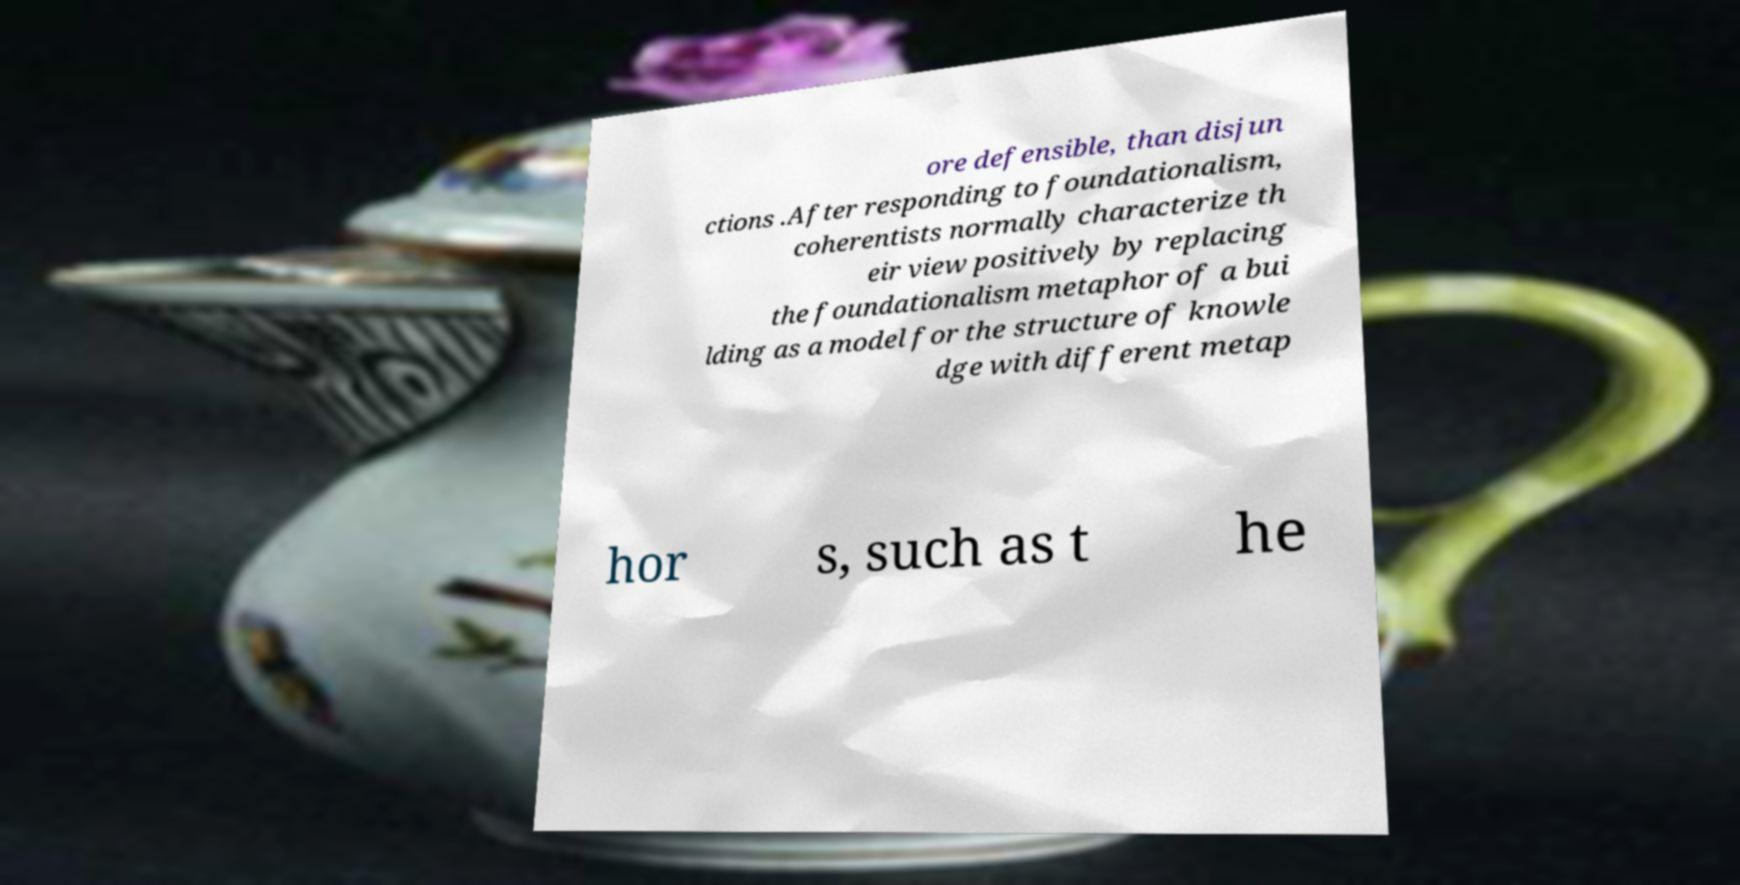Can you read and provide the text displayed in the image?This photo seems to have some interesting text. Can you extract and type it out for me? ore defensible, than disjun ctions .After responding to foundationalism, coherentists normally characterize th eir view positively by replacing the foundationalism metaphor of a bui lding as a model for the structure of knowle dge with different metap hor s, such as t he 